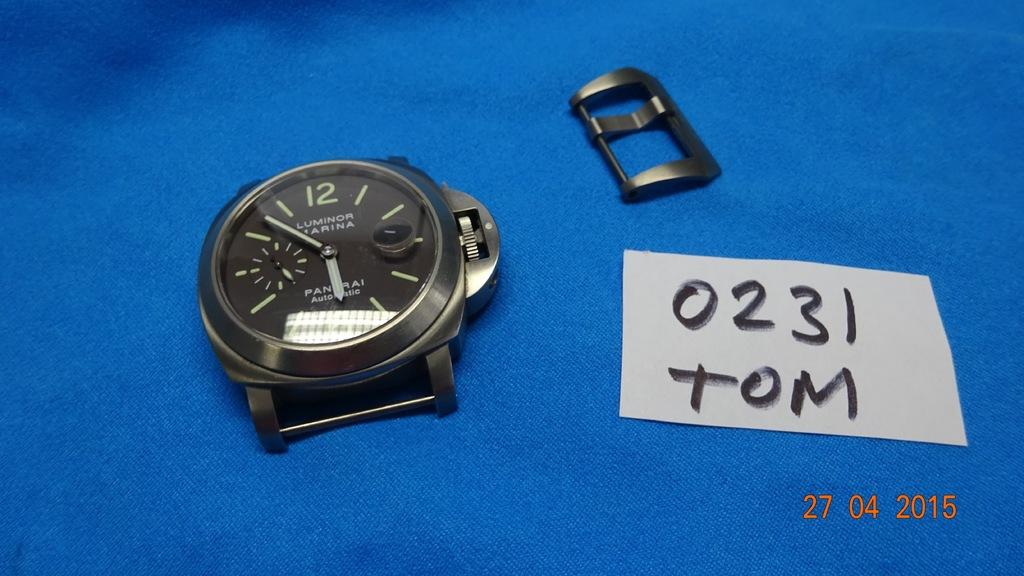<image>
Write a terse but informative summary of the picture. Face of a watch next to a piece of paper that says "0231 tom". 